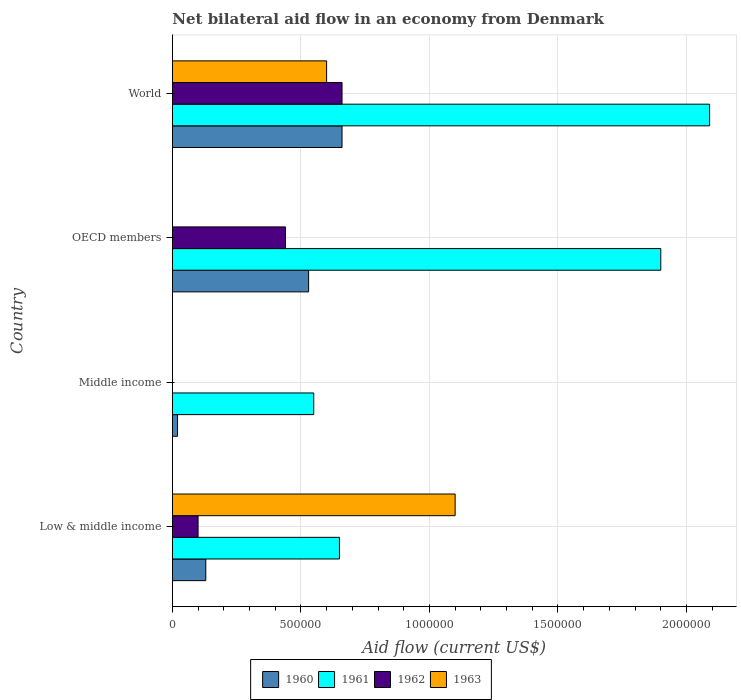How many different coloured bars are there?
Offer a terse response. 4. How many groups of bars are there?
Make the answer very short. 4. Are the number of bars per tick equal to the number of legend labels?
Keep it short and to the point. No. How many bars are there on the 2nd tick from the top?
Your response must be concise. 3. What is the label of the 1st group of bars from the top?
Keep it short and to the point. World. In how many cases, is the number of bars for a given country not equal to the number of legend labels?
Give a very brief answer. 2. What is the net bilateral aid flow in 1961 in Low & middle income?
Your answer should be compact. 6.50e+05. Across all countries, what is the maximum net bilateral aid flow in 1960?
Make the answer very short. 6.60e+05. What is the total net bilateral aid flow in 1962 in the graph?
Offer a very short reply. 1.20e+06. What is the difference between the net bilateral aid flow in 1960 in Low & middle income and that in OECD members?
Your answer should be compact. -4.00e+05. What is the difference between the net bilateral aid flow in 1962 in Middle income and the net bilateral aid flow in 1960 in World?
Give a very brief answer. -6.60e+05. What is the average net bilateral aid flow in 1960 per country?
Your answer should be compact. 3.35e+05. What is the difference between the net bilateral aid flow in 1961 and net bilateral aid flow in 1962 in OECD members?
Make the answer very short. 1.46e+06. In how many countries, is the net bilateral aid flow in 1963 greater than 1000000 US$?
Ensure brevity in your answer.  1. What is the ratio of the net bilateral aid flow in 1961 in Middle income to that in OECD members?
Keep it short and to the point. 0.29. Is the net bilateral aid flow in 1961 in Middle income less than that in World?
Give a very brief answer. Yes. Is the difference between the net bilateral aid flow in 1961 in OECD members and World greater than the difference between the net bilateral aid flow in 1962 in OECD members and World?
Your response must be concise. Yes. What is the difference between the highest and the lowest net bilateral aid flow in 1962?
Provide a short and direct response. 6.60e+05. In how many countries, is the net bilateral aid flow in 1963 greater than the average net bilateral aid flow in 1963 taken over all countries?
Keep it short and to the point. 2. Is the sum of the net bilateral aid flow in 1960 in Low & middle income and World greater than the maximum net bilateral aid flow in 1963 across all countries?
Your answer should be very brief. No. Is it the case that in every country, the sum of the net bilateral aid flow in 1962 and net bilateral aid flow in 1963 is greater than the sum of net bilateral aid flow in 1961 and net bilateral aid flow in 1960?
Offer a very short reply. No. Is it the case that in every country, the sum of the net bilateral aid flow in 1962 and net bilateral aid flow in 1960 is greater than the net bilateral aid flow in 1961?
Provide a short and direct response. No. How many bars are there?
Your response must be concise. 13. What is the difference between two consecutive major ticks on the X-axis?
Make the answer very short. 5.00e+05. Are the values on the major ticks of X-axis written in scientific E-notation?
Provide a short and direct response. No. Does the graph contain any zero values?
Keep it short and to the point. Yes. How many legend labels are there?
Ensure brevity in your answer.  4. What is the title of the graph?
Your answer should be compact. Net bilateral aid flow in an economy from Denmark. Does "1961" appear as one of the legend labels in the graph?
Offer a terse response. Yes. What is the label or title of the X-axis?
Provide a succinct answer. Aid flow (current US$). What is the Aid flow (current US$) of 1961 in Low & middle income?
Make the answer very short. 6.50e+05. What is the Aid flow (current US$) of 1962 in Low & middle income?
Ensure brevity in your answer.  1.00e+05. What is the Aid flow (current US$) in 1963 in Low & middle income?
Your answer should be compact. 1.10e+06. What is the Aid flow (current US$) of 1960 in Middle income?
Make the answer very short. 2.00e+04. What is the Aid flow (current US$) in 1961 in Middle income?
Keep it short and to the point. 5.50e+05. What is the Aid flow (current US$) of 1963 in Middle income?
Your response must be concise. 0. What is the Aid flow (current US$) of 1960 in OECD members?
Your response must be concise. 5.30e+05. What is the Aid flow (current US$) of 1961 in OECD members?
Your answer should be compact. 1.90e+06. What is the Aid flow (current US$) of 1962 in OECD members?
Ensure brevity in your answer.  4.40e+05. What is the Aid flow (current US$) in 1960 in World?
Give a very brief answer. 6.60e+05. What is the Aid flow (current US$) of 1961 in World?
Keep it short and to the point. 2.09e+06. What is the Aid flow (current US$) of 1962 in World?
Give a very brief answer. 6.60e+05. Across all countries, what is the maximum Aid flow (current US$) in 1961?
Provide a succinct answer. 2.09e+06. Across all countries, what is the maximum Aid flow (current US$) of 1963?
Provide a short and direct response. 1.10e+06. Across all countries, what is the minimum Aid flow (current US$) in 1963?
Give a very brief answer. 0. What is the total Aid flow (current US$) of 1960 in the graph?
Make the answer very short. 1.34e+06. What is the total Aid flow (current US$) in 1961 in the graph?
Your response must be concise. 5.19e+06. What is the total Aid flow (current US$) in 1962 in the graph?
Provide a short and direct response. 1.20e+06. What is the total Aid flow (current US$) in 1963 in the graph?
Your answer should be compact. 1.70e+06. What is the difference between the Aid flow (current US$) of 1960 in Low & middle income and that in Middle income?
Your answer should be very brief. 1.10e+05. What is the difference between the Aid flow (current US$) of 1961 in Low & middle income and that in Middle income?
Keep it short and to the point. 1.00e+05. What is the difference between the Aid flow (current US$) in 1960 in Low & middle income and that in OECD members?
Provide a short and direct response. -4.00e+05. What is the difference between the Aid flow (current US$) in 1961 in Low & middle income and that in OECD members?
Your response must be concise. -1.25e+06. What is the difference between the Aid flow (current US$) of 1960 in Low & middle income and that in World?
Your response must be concise. -5.30e+05. What is the difference between the Aid flow (current US$) in 1961 in Low & middle income and that in World?
Give a very brief answer. -1.44e+06. What is the difference between the Aid flow (current US$) in 1962 in Low & middle income and that in World?
Ensure brevity in your answer.  -5.60e+05. What is the difference between the Aid flow (current US$) in 1963 in Low & middle income and that in World?
Provide a short and direct response. 5.00e+05. What is the difference between the Aid flow (current US$) of 1960 in Middle income and that in OECD members?
Your response must be concise. -5.10e+05. What is the difference between the Aid flow (current US$) of 1961 in Middle income and that in OECD members?
Offer a very short reply. -1.35e+06. What is the difference between the Aid flow (current US$) in 1960 in Middle income and that in World?
Offer a terse response. -6.40e+05. What is the difference between the Aid flow (current US$) in 1961 in Middle income and that in World?
Provide a short and direct response. -1.54e+06. What is the difference between the Aid flow (current US$) in 1961 in OECD members and that in World?
Your response must be concise. -1.90e+05. What is the difference between the Aid flow (current US$) in 1962 in OECD members and that in World?
Provide a short and direct response. -2.20e+05. What is the difference between the Aid flow (current US$) in 1960 in Low & middle income and the Aid flow (current US$) in 1961 in Middle income?
Your answer should be compact. -4.20e+05. What is the difference between the Aid flow (current US$) of 1960 in Low & middle income and the Aid flow (current US$) of 1961 in OECD members?
Make the answer very short. -1.77e+06. What is the difference between the Aid flow (current US$) in 1960 in Low & middle income and the Aid flow (current US$) in 1962 in OECD members?
Keep it short and to the point. -3.10e+05. What is the difference between the Aid flow (current US$) in 1960 in Low & middle income and the Aid flow (current US$) in 1961 in World?
Provide a short and direct response. -1.96e+06. What is the difference between the Aid flow (current US$) in 1960 in Low & middle income and the Aid flow (current US$) in 1962 in World?
Give a very brief answer. -5.30e+05. What is the difference between the Aid flow (current US$) in 1960 in Low & middle income and the Aid flow (current US$) in 1963 in World?
Make the answer very short. -4.70e+05. What is the difference between the Aid flow (current US$) in 1962 in Low & middle income and the Aid flow (current US$) in 1963 in World?
Your answer should be compact. -5.00e+05. What is the difference between the Aid flow (current US$) of 1960 in Middle income and the Aid flow (current US$) of 1961 in OECD members?
Keep it short and to the point. -1.88e+06. What is the difference between the Aid flow (current US$) of 1960 in Middle income and the Aid flow (current US$) of 1962 in OECD members?
Keep it short and to the point. -4.20e+05. What is the difference between the Aid flow (current US$) in 1960 in Middle income and the Aid flow (current US$) in 1961 in World?
Your answer should be compact. -2.07e+06. What is the difference between the Aid flow (current US$) in 1960 in Middle income and the Aid flow (current US$) in 1962 in World?
Keep it short and to the point. -6.40e+05. What is the difference between the Aid flow (current US$) in 1960 in Middle income and the Aid flow (current US$) in 1963 in World?
Provide a succinct answer. -5.80e+05. What is the difference between the Aid flow (current US$) of 1961 in Middle income and the Aid flow (current US$) of 1963 in World?
Your answer should be very brief. -5.00e+04. What is the difference between the Aid flow (current US$) of 1960 in OECD members and the Aid flow (current US$) of 1961 in World?
Your answer should be very brief. -1.56e+06. What is the difference between the Aid flow (current US$) in 1960 in OECD members and the Aid flow (current US$) in 1962 in World?
Your answer should be compact. -1.30e+05. What is the difference between the Aid flow (current US$) in 1960 in OECD members and the Aid flow (current US$) in 1963 in World?
Your answer should be very brief. -7.00e+04. What is the difference between the Aid flow (current US$) of 1961 in OECD members and the Aid flow (current US$) of 1962 in World?
Offer a very short reply. 1.24e+06. What is the difference between the Aid flow (current US$) of 1961 in OECD members and the Aid flow (current US$) of 1963 in World?
Offer a very short reply. 1.30e+06. What is the difference between the Aid flow (current US$) of 1962 in OECD members and the Aid flow (current US$) of 1963 in World?
Provide a succinct answer. -1.60e+05. What is the average Aid flow (current US$) of 1960 per country?
Make the answer very short. 3.35e+05. What is the average Aid flow (current US$) of 1961 per country?
Keep it short and to the point. 1.30e+06. What is the average Aid flow (current US$) of 1962 per country?
Your answer should be compact. 3.00e+05. What is the average Aid flow (current US$) in 1963 per country?
Your answer should be compact. 4.25e+05. What is the difference between the Aid flow (current US$) of 1960 and Aid flow (current US$) of 1961 in Low & middle income?
Your response must be concise. -5.20e+05. What is the difference between the Aid flow (current US$) in 1960 and Aid flow (current US$) in 1963 in Low & middle income?
Your answer should be compact. -9.70e+05. What is the difference between the Aid flow (current US$) in 1961 and Aid flow (current US$) in 1963 in Low & middle income?
Provide a short and direct response. -4.50e+05. What is the difference between the Aid flow (current US$) in 1962 and Aid flow (current US$) in 1963 in Low & middle income?
Ensure brevity in your answer.  -1.00e+06. What is the difference between the Aid flow (current US$) in 1960 and Aid flow (current US$) in 1961 in Middle income?
Provide a short and direct response. -5.30e+05. What is the difference between the Aid flow (current US$) of 1960 and Aid flow (current US$) of 1961 in OECD members?
Make the answer very short. -1.37e+06. What is the difference between the Aid flow (current US$) in 1960 and Aid flow (current US$) in 1962 in OECD members?
Your answer should be compact. 9.00e+04. What is the difference between the Aid flow (current US$) of 1961 and Aid flow (current US$) of 1962 in OECD members?
Your answer should be compact. 1.46e+06. What is the difference between the Aid flow (current US$) in 1960 and Aid flow (current US$) in 1961 in World?
Give a very brief answer. -1.43e+06. What is the difference between the Aid flow (current US$) of 1961 and Aid flow (current US$) of 1962 in World?
Offer a very short reply. 1.43e+06. What is the difference between the Aid flow (current US$) of 1961 and Aid flow (current US$) of 1963 in World?
Ensure brevity in your answer.  1.49e+06. What is the ratio of the Aid flow (current US$) of 1961 in Low & middle income to that in Middle income?
Your answer should be very brief. 1.18. What is the ratio of the Aid flow (current US$) in 1960 in Low & middle income to that in OECD members?
Offer a terse response. 0.25. What is the ratio of the Aid flow (current US$) in 1961 in Low & middle income to that in OECD members?
Your answer should be very brief. 0.34. What is the ratio of the Aid flow (current US$) of 1962 in Low & middle income to that in OECD members?
Your response must be concise. 0.23. What is the ratio of the Aid flow (current US$) in 1960 in Low & middle income to that in World?
Offer a terse response. 0.2. What is the ratio of the Aid flow (current US$) in 1961 in Low & middle income to that in World?
Ensure brevity in your answer.  0.31. What is the ratio of the Aid flow (current US$) of 1962 in Low & middle income to that in World?
Your response must be concise. 0.15. What is the ratio of the Aid flow (current US$) of 1963 in Low & middle income to that in World?
Provide a short and direct response. 1.83. What is the ratio of the Aid flow (current US$) in 1960 in Middle income to that in OECD members?
Your response must be concise. 0.04. What is the ratio of the Aid flow (current US$) in 1961 in Middle income to that in OECD members?
Provide a short and direct response. 0.29. What is the ratio of the Aid flow (current US$) of 1960 in Middle income to that in World?
Give a very brief answer. 0.03. What is the ratio of the Aid flow (current US$) of 1961 in Middle income to that in World?
Give a very brief answer. 0.26. What is the ratio of the Aid flow (current US$) in 1960 in OECD members to that in World?
Offer a terse response. 0.8. What is the difference between the highest and the second highest Aid flow (current US$) in 1960?
Make the answer very short. 1.30e+05. What is the difference between the highest and the second highest Aid flow (current US$) of 1961?
Your answer should be very brief. 1.90e+05. What is the difference between the highest and the second highest Aid flow (current US$) in 1962?
Make the answer very short. 2.20e+05. What is the difference between the highest and the lowest Aid flow (current US$) in 1960?
Your answer should be very brief. 6.40e+05. What is the difference between the highest and the lowest Aid flow (current US$) of 1961?
Make the answer very short. 1.54e+06. What is the difference between the highest and the lowest Aid flow (current US$) of 1963?
Your response must be concise. 1.10e+06. 